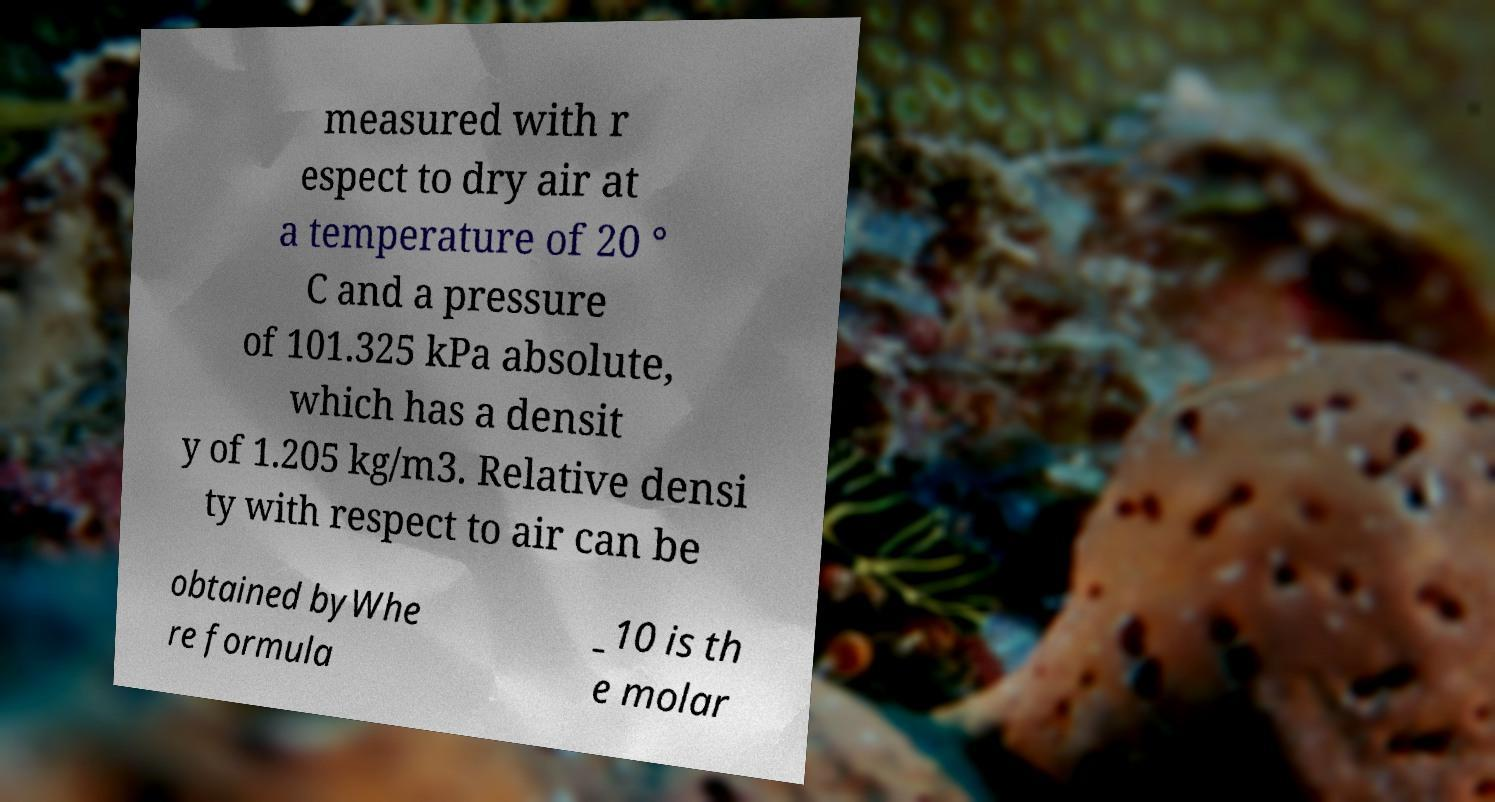I need the written content from this picture converted into text. Can you do that? measured with r espect to dry air at a temperature of 20 ° C and a pressure of 101.325 kPa absolute, which has a densit y of 1.205 kg/m3. Relative densi ty with respect to air can be obtained byWhe re formula _10 is th e molar 